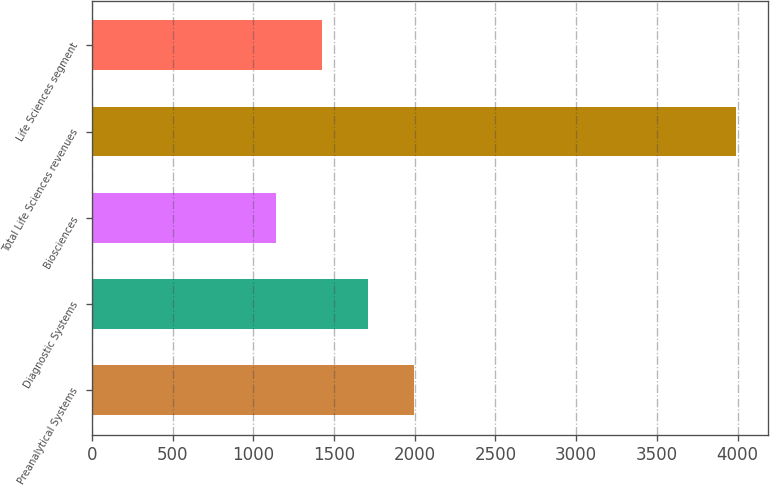Convert chart. <chart><loc_0><loc_0><loc_500><loc_500><bar_chart><fcel>Preanalytical Systems<fcel>Diagnostic Systems<fcel>Biosciences<fcel>Total Life Sciences revenues<fcel>Life Sciences segment<nl><fcel>1993.7<fcel>1708.8<fcel>1139<fcel>3988<fcel>1423.9<nl></chart> 